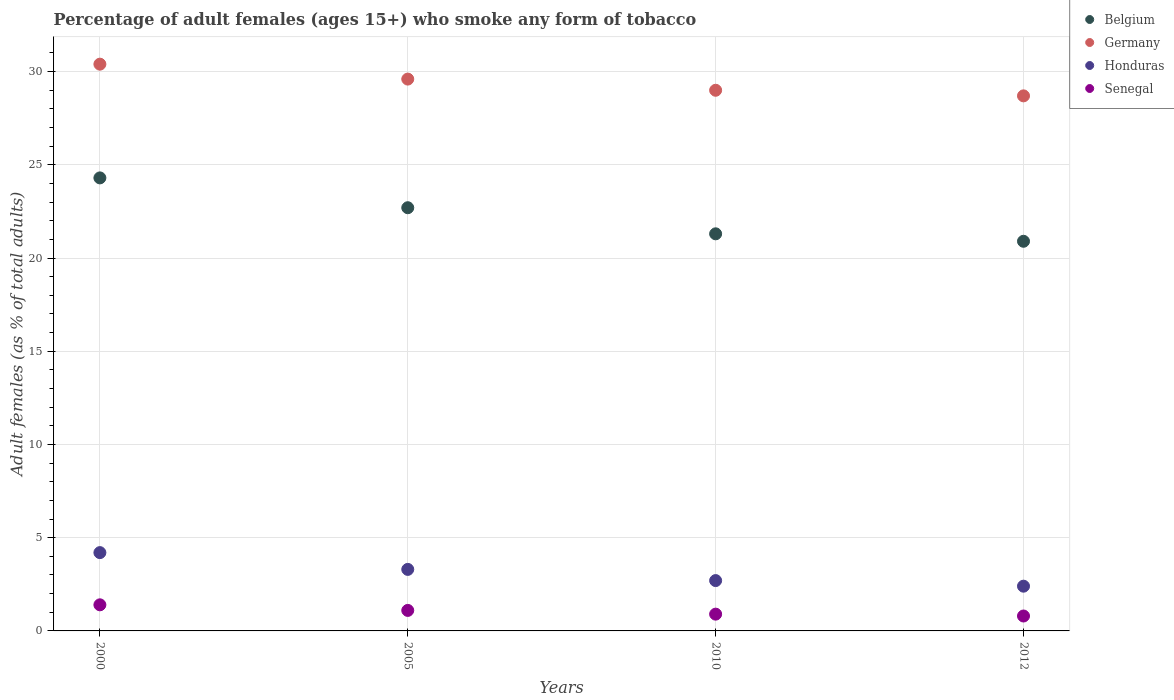Is the number of dotlines equal to the number of legend labels?
Your answer should be very brief. Yes. What is the percentage of adult females who smoke in Belgium in 2010?
Ensure brevity in your answer.  21.3. Across all years, what is the maximum percentage of adult females who smoke in Belgium?
Your response must be concise. 24.3. Across all years, what is the minimum percentage of adult females who smoke in Germany?
Your answer should be very brief. 28.7. In which year was the percentage of adult females who smoke in Honduras minimum?
Ensure brevity in your answer.  2012. What is the total percentage of adult females who smoke in Germany in the graph?
Offer a very short reply. 117.7. What is the difference between the percentage of adult females who smoke in Senegal in 2005 and that in 2010?
Offer a very short reply. 0.2. What is the difference between the percentage of adult females who smoke in Honduras in 2012 and the percentage of adult females who smoke in Senegal in 2010?
Your response must be concise. 1.5. What is the average percentage of adult females who smoke in Germany per year?
Provide a succinct answer. 29.43. In the year 2000, what is the difference between the percentage of adult females who smoke in Senegal and percentage of adult females who smoke in Honduras?
Provide a succinct answer. -2.8. In how many years, is the percentage of adult females who smoke in Belgium greater than 22 %?
Offer a terse response. 2. What is the ratio of the percentage of adult females who smoke in Germany in 2000 to that in 2005?
Give a very brief answer. 1.03. Is the percentage of adult females who smoke in Honduras in 2000 less than that in 2012?
Your response must be concise. No. Is the difference between the percentage of adult females who smoke in Senegal in 2000 and 2010 greater than the difference between the percentage of adult females who smoke in Honduras in 2000 and 2010?
Provide a succinct answer. No. What is the difference between the highest and the second highest percentage of adult females who smoke in Germany?
Provide a succinct answer. 0.8. What is the difference between the highest and the lowest percentage of adult females who smoke in Senegal?
Your answer should be very brief. 0.6. Is the sum of the percentage of adult females who smoke in Honduras in 2005 and 2010 greater than the maximum percentage of adult females who smoke in Germany across all years?
Your answer should be compact. No. Is it the case that in every year, the sum of the percentage of adult females who smoke in Honduras and percentage of adult females who smoke in Belgium  is greater than the percentage of adult females who smoke in Germany?
Your answer should be very brief. No. Does the percentage of adult females who smoke in Senegal monotonically increase over the years?
Your answer should be very brief. No. Is the percentage of adult females who smoke in Honduras strictly less than the percentage of adult females who smoke in Senegal over the years?
Your response must be concise. No. How many dotlines are there?
Your answer should be compact. 4. What is the difference between two consecutive major ticks on the Y-axis?
Provide a short and direct response. 5. Does the graph contain grids?
Provide a succinct answer. Yes. Where does the legend appear in the graph?
Offer a very short reply. Top right. How many legend labels are there?
Offer a very short reply. 4. What is the title of the graph?
Your answer should be very brief. Percentage of adult females (ages 15+) who smoke any form of tobacco. Does "European Union" appear as one of the legend labels in the graph?
Provide a short and direct response. No. What is the label or title of the Y-axis?
Offer a very short reply. Adult females (as % of total adults). What is the Adult females (as % of total adults) of Belgium in 2000?
Ensure brevity in your answer.  24.3. What is the Adult females (as % of total adults) in Germany in 2000?
Provide a succinct answer. 30.4. What is the Adult females (as % of total adults) in Belgium in 2005?
Your answer should be compact. 22.7. What is the Adult females (as % of total adults) in Germany in 2005?
Make the answer very short. 29.6. What is the Adult females (as % of total adults) in Honduras in 2005?
Offer a very short reply. 3.3. What is the Adult females (as % of total adults) in Belgium in 2010?
Keep it short and to the point. 21.3. What is the Adult females (as % of total adults) in Senegal in 2010?
Make the answer very short. 0.9. What is the Adult females (as % of total adults) in Belgium in 2012?
Give a very brief answer. 20.9. What is the Adult females (as % of total adults) of Germany in 2012?
Keep it short and to the point. 28.7. What is the Adult females (as % of total adults) in Honduras in 2012?
Provide a succinct answer. 2.4. Across all years, what is the maximum Adult females (as % of total adults) of Belgium?
Offer a terse response. 24.3. Across all years, what is the maximum Adult females (as % of total adults) in Germany?
Your answer should be compact. 30.4. Across all years, what is the minimum Adult females (as % of total adults) of Belgium?
Ensure brevity in your answer.  20.9. Across all years, what is the minimum Adult females (as % of total adults) of Germany?
Your answer should be very brief. 28.7. Across all years, what is the minimum Adult females (as % of total adults) of Honduras?
Make the answer very short. 2.4. Across all years, what is the minimum Adult females (as % of total adults) in Senegal?
Your answer should be very brief. 0.8. What is the total Adult females (as % of total adults) in Belgium in the graph?
Provide a succinct answer. 89.2. What is the total Adult females (as % of total adults) in Germany in the graph?
Your answer should be compact. 117.7. What is the difference between the Adult females (as % of total adults) of Honduras in 2000 and that in 2005?
Offer a terse response. 0.9. What is the difference between the Adult females (as % of total adults) in Senegal in 2000 and that in 2005?
Provide a succinct answer. 0.3. What is the difference between the Adult females (as % of total adults) in Germany in 2000 and that in 2010?
Make the answer very short. 1.4. What is the difference between the Adult females (as % of total adults) of Honduras in 2000 and that in 2010?
Provide a succinct answer. 1.5. What is the difference between the Adult females (as % of total adults) of Belgium in 2000 and that in 2012?
Your answer should be very brief. 3.4. What is the difference between the Adult females (as % of total adults) of Senegal in 2000 and that in 2012?
Give a very brief answer. 0.6. What is the difference between the Adult females (as % of total adults) in Germany in 2005 and that in 2010?
Make the answer very short. 0.6. What is the difference between the Adult females (as % of total adults) of Honduras in 2005 and that in 2010?
Make the answer very short. 0.6. What is the difference between the Adult females (as % of total adults) in Germany in 2005 and that in 2012?
Ensure brevity in your answer.  0.9. What is the difference between the Adult females (as % of total adults) of Honduras in 2005 and that in 2012?
Offer a terse response. 0.9. What is the difference between the Adult females (as % of total adults) in Senegal in 2005 and that in 2012?
Offer a terse response. 0.3. What is the difference between the Adult females (as % of total adults) in Germany in 2010 and that in 2012?
Give a very brief answer. 0.3. What is the difference between the Adult females (as % of total adults) of Belgium in 2000 and the Adult females (as % of total adults) of Germany in 2005?
Keep it short and to the point. -5.3. What is the difference between the Adult females (as % of total adults) in Belgium in 2000 and the Adult females (as % of total adults) in Honduras in 2005?
Your answer should be compact. 21. What is the difference between the Adult females (as % of total adults) in Belgium in 2000 and the Adult females (as % of total adults) in Senegal in 2005?
Offer a very short reply. 23.2. What is the difference between the Adult females (as % of total adults) of Germany in 2000 and the Adult females (as % of total adults) of Honduras in 2005?
Provide a succinct answer. 27.1. What is the difference between the Adult females (as % of total adults) in Germany in 2000 and the Adult females (as % of total adults) in Senegal in 2005?
Provide a short and direct response. 29.3. What is the difference between the Adult females (as % of total adults) of Belgium in 2000 and the Adult females (as % of total adults) of Germany in 2010?
Give a very brief answer. -4.7. What is the difference between the Adult females (as % of total adults) in Belgium in 2000 and the Adult females (as % of total adults) in Honduras in 2010?
Offer a terse response. 21.6. What is the difference between the Adult females (as % of total adults) of Belgium in 2000 and the Adult females (as % of total adults) of Senegal in 2010?
Offer a terse response. 23.4. What is the difference between the Adult females (as % of total adults) of Germany in 2000 and the Adult females (as % of total adults) of Honduras in 2010?
Make the answer very short. 27.7. What is the difference between the Adult females (as % of total adults) in Germany in 2000 and the Adult females (as % of total adults) in Senegal in 2010?
Make the answer very short. 29.5. What is the difference between the Adult females (as % of total adults) of Belgium in 2000 and the Adult females (as % of total adults) of Honduras in 2012?
Your answer should be compact. 21.9. What is the difference between the Adult females (as % of total adults) of Germany in 2000 and the Adult females (as % of total adults) of Senegal in 2012?
Offer a terse response. 29.6. What is the difference between the Adult females (as % of total adults) in Honduras in 2000 and the Adult females (as % of total adults) in Senegal in 2012?
Offer a terse response. 3.4. What is the difference between the Adult females (as % of total adults) in Belgium in 2005 and the Adult females (as % of total adults) in Senegal in 2010?
Your response must be concise. 21.8. What is the difference between the Adult females (as % of total adults) of Germany in 2005 and the Adult females (as % of total adults) of Honduras in 2010?
Your response must be concise. 26.9. What is the difference between the Adult females (as % of total adults) in Germany in 2005 and the Adult females (as % of total adults) in Senegal in 2010?
Make the answer very short. 28.7. What is the difference between the Adult females (as % of total adults) of Honduras in 2005 and the Adult females (as % of total adults) of Senegal in 2010?
Offer a terse response. 2.4. What is the difference between the Adult females (as % of total adults) in Belgium in 2005 and the Adult females (as % of total adults) in Germany in 2012?
Your answer should be compact. -6. What is the difference between the Adult females (as % of total adults) of Belgium in 2005 and the Adult females (as % of total adults) of Honduras in 2012?
Ensure brevity in your answer.  20.3. What is the difference between the Adult females (as % of total adults) of Belgium in 2005 and the Adult females (as % of total adults) of Senegal in 2012?
Keep it short and to the point. 21.9. What is the difference between the Adult females (as % of total adults) in Germany in 2005 and the Adult females (as % of total adults) in Honduras in 2012?
Offer a very short reply. 27.2. What is the difference between the Adult females (as % of total adults) of Germany in 2005 and the Adult females (as % of total adults) of Senegal in 2012?
Provide a short and direct response. 28.8. What is the difference between the Adult females (as % of total adults) of Honduras in 2005 and the Adult females (as % of total adults) of Senegal in 2012?
Make the answer very short. 2.5. What is the difference between the Adult females (as % of total adults) of Belgium in 2010 and the Adult females (as % of total adults) of Germany in 2012?
Your answer should be very brief. -7.4. What is the difference between the Adult females (as % of total adults) in Belgium in 2010 and the Adult females (as % of total adults) in Honduras in 2012?
Provide a short and direct response. 18.9. What is the difference between the Adult females (as % of total adults) in Belgium in 2010 and the Adult females (as % of total adults) in Senegal in 2012?
Make the answer very short. 20.5. What is the difference between the Adult females (as % of total adults) in Germany in 2010 and the Adult females (as % of total adults) in Honduras in 2012?
Offer a terse response. 26.6. What is the difference between the Adult females (as % of total adults) in Germany in 2010 and the Adult females (as % of total adults) in Senegal in 2012?
Offer a very short reply. 28.2. What is the average Adult females (as % of total adults) in Belgium per year?
Your response must be concise. 22.3. What is the average Adult females (as % of total adults) in Germany per year?
Your response must be concise. 29.43. What is the average Adult females (as % of total adults) in Honduras per year?
Keep it short and to the point. 3.15. In the year 2000, what is the difference between the Adult females (as % of total adults) of Belgium and Adult females (as % of total adults) of Germany?
Give a very brief answer. -6.1. In the year 2000, what is the difference between the Adult females (as % of total adults) in Belgium and Adult females (as % of total adults) in Honduras?
Provide a succinct answer. 20.1. In the year 2000, what is the difference between the Adult females (as % of total adults) in Belgium and Adult females (as % of total adults) in Senegal?
Offer a very short reply. 22.9. In the year 2000, what is the difference between the Adult females (as % of total adults) of Germany and Adult females (as % of total adults) of Honduras?
Offer a very short reply. 26.2. In the year 2005, what is the difference between the Adult females (as % of total adults) in Belgium and Adult females (as % of total adults) in Germany?
Provide a succinct answer. -6.9. In the year 2005, what is the difference between the Adult females (as % of total adults) of Belgium and Adult females (as % of total adults) of Senegal?
Offer a terse response. 21.6. In the year 2005, what is the difference between the Adult females (as % of total adults) in Germany and Adult females (as % of total adults) in Honduras?
Keep it short and to the point. 26.3. In the year 2005, what is the difference between the Adult females (as % of total adults) in Germany and Adult females (as % of total adults) in Senegal?
Make the answer very short. 28.5. In the year 2010, what is the difference between the Adult females (as % of total adults) in Belgium and Adult females (as % of total adults) in Honduras?
Your answer should be very brief. 18.6. In the year 2010, what is the difference between the Adult females (as % of total adults) in Belgium and Adult females (as % of total adults) in Senegal?
Keep it short and to the point. 20.4. In the year 2010, what is the difference between the Adult females (as % of total adults) in Germany and Adult females (as % of total adults) in Honduras?
Provide a succinct answer. 26.3. In the year 2010, what is the difference between the Adult females (as % of total adults) in Germany and Adult females (as % of total adults) in Senegal?
Give a very brief answer. 28.1. In the year 2010, what is the difference between the Adult females (as % of total adults) of Honduras and Adult females (as % of total adults) of Senegal?
Keep it short and to the point. 1.8. In the year 2012, what is the difference between the Adult females (as % of total adults) in Belgium and Adult females (as % of total adults) in Senegal?
Keep it short and to the point. 20.1. In the year 2012, what is the difference between the Adult females (as % of total adults) in Germany and Adult females (as % of total adults) in Honduras?
Keep it short and to the point. 26.3. In the year 2012, what is the difference between the Adult females (as % of total adults) in Germany and Adult females (as % of total adults) in Senegal?
Offer a terse response. 27.9. In the year 2012, what is the difference between the Adult females (as % of total adults) of Honduras and Adult females (as % of total adults) of Senegal?
Your answer should be compact. 1.6. What is the ratio of the Adult females (as % of total adults) of Belgium in 2000 to that in 2005?
Ensure brevity in your answer.  1.07. What is the ratio of the Adult females (as % of total adults) of Honduras in 2000 to that in 2005?
Provide a succinct answer. 1.27. What is the ratio of the Adult females (as % of total adults) of Senegal in 2000 to that in 2005?
Your response must be concise. 1.27. What is the ratio of the Adult females (as % of total adults) in Belgium in 2000 to that in 2010?
Keep it short and to the point. 1.14. What is the ratio of the Adult females (as % of total adults) of Germany in 2000 to that in 2010?
Give a very brief answer. 1.05. What is the ratio of the Adult females (as % of total adults) in Honduras in 2000 to that in 2010?
Provide a succinct answer. 1.56. What is the ratio of the Adult females (as % of total adults) of Senegal in 2000 to that in 2010?
Ensure brevity in your answer.  1.56. What is the ratio of the Adult females (as % of total adults) of Belgium in 2000 to that in 2012?
Offer a terse response. 1.16. What is the ratio of the Adult females (as % of total adults) of Germany in 2000 to that in 2012?
Your response must be concise. 1.06. What is the ratio of the Adult females (as % of total adults) in Belgium in 2005 to that in 2010?
Make the answer very short. 1.07. What is the ratio of the Adult females (as % of total adults) in Germany in 2005 to that in 2010?
Make the answer very short. 1.02. What is the ratio of the Adult females (as % of total adults) of Honduras in 2005 to that in 2010?
Offer a very short reply. 1.22. What is the ratio of the Adult females (as % of total adults) in Senegal in 2005 to that in 2010?
Keep it short and to the point. 1.22. What is the ratio of the Adult females (as % of total adults) in Belgium in 2005 to that in 2012?
Provide a succinct answer. 1.09. What is the ratio of the Adult females (as % of total adults) in Germany in 2005 to that in 2012?
Offer a terse response. 1.03. What is the ratio of the Adult females (as % of total adults) of Honduras in 2005 to that in 2012?
Offer a terse response. 1.38. What is the ratio of the Adult females (as % of total adults) in Senegal in 2005 to that in 2012?
Ensure brevity in your answer.  1.38. What is the ratio of the Adult females (as % of total adults) of Belgium in 2010 to that in 2012?
Your answer should be very brief. 1.02. What is the ratio of the Adult females (as % of total adults) in Germany in 2010 to that in 2012?
Offer a very short reply. 1.01. What is the difference between the highest and the second highest Adult females (as % of total adults) in Senegal?
Ensure brevity in your answer.  0.3. What is the difference between the highest and the lowest Adult females (as % of total adults) of Belgium?
Give a very brief answer. 3.4. What is the difference between the highest and the lowest Adult females (as % of total adults) of Honduras?
Give a very brief answer. 1.8. What is the difference between the highest and the lowest Adult females (as % of total adults) of Senegal?
Offer a very short reply. 0.6. 